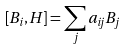<formula> <loc_0><loc_0><loc_500><loc_500>\left [ B _ { i } , H \right ] = \sum _ { j } a _ { i j } B _ { j }</formula> 